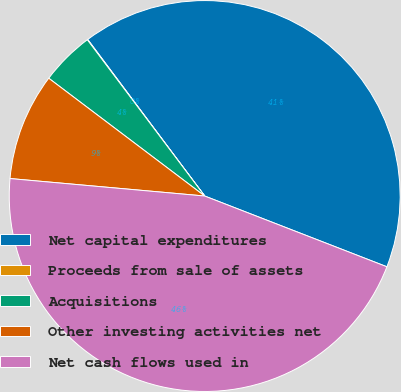Convert chart to OTSL. <chart><loc_0><loc_0><loc_500><loc_500><pie_chart><fcel>Net capital expenditures<fcel>Proceeds from sale of assets<fcel>Acquisitions<fcel>Other investing activities net<fcel>Net cash flows used in<nl><fcel>41.11%<fcel>0.04%<fcel>4.45%<fcel>8.87%<fcel>45.53%<nl></chart> 